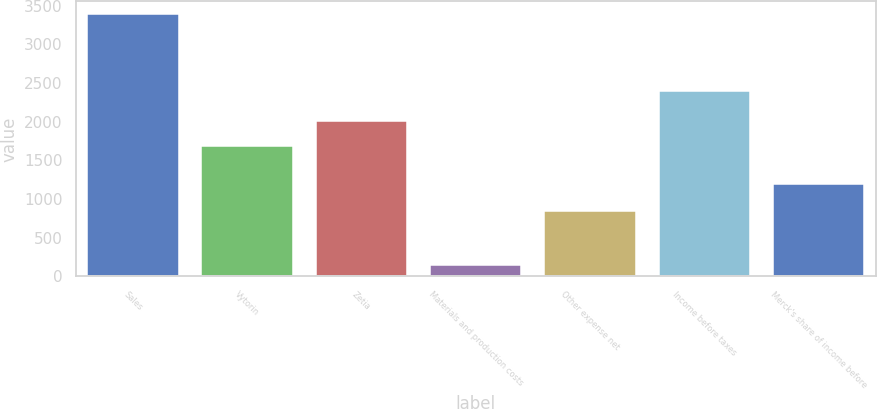Convert chart to OTSL. <chart><loc_0><loc_0><loc_500><loc_500><bar_chart><fcel>Sales<fcel>Vytorin<fcel>Zetia<fcel>Materials and production costs<fcel>Other expense net<fcel>Income before taxes<fcel>Merck's share of income before<nl><fcel>3387.2<fcel>1689.5<fcel>2013.78<fcel>144.4<fcel>848.7<fcel>2394.1<fcel>1197.7<nl></chart> 